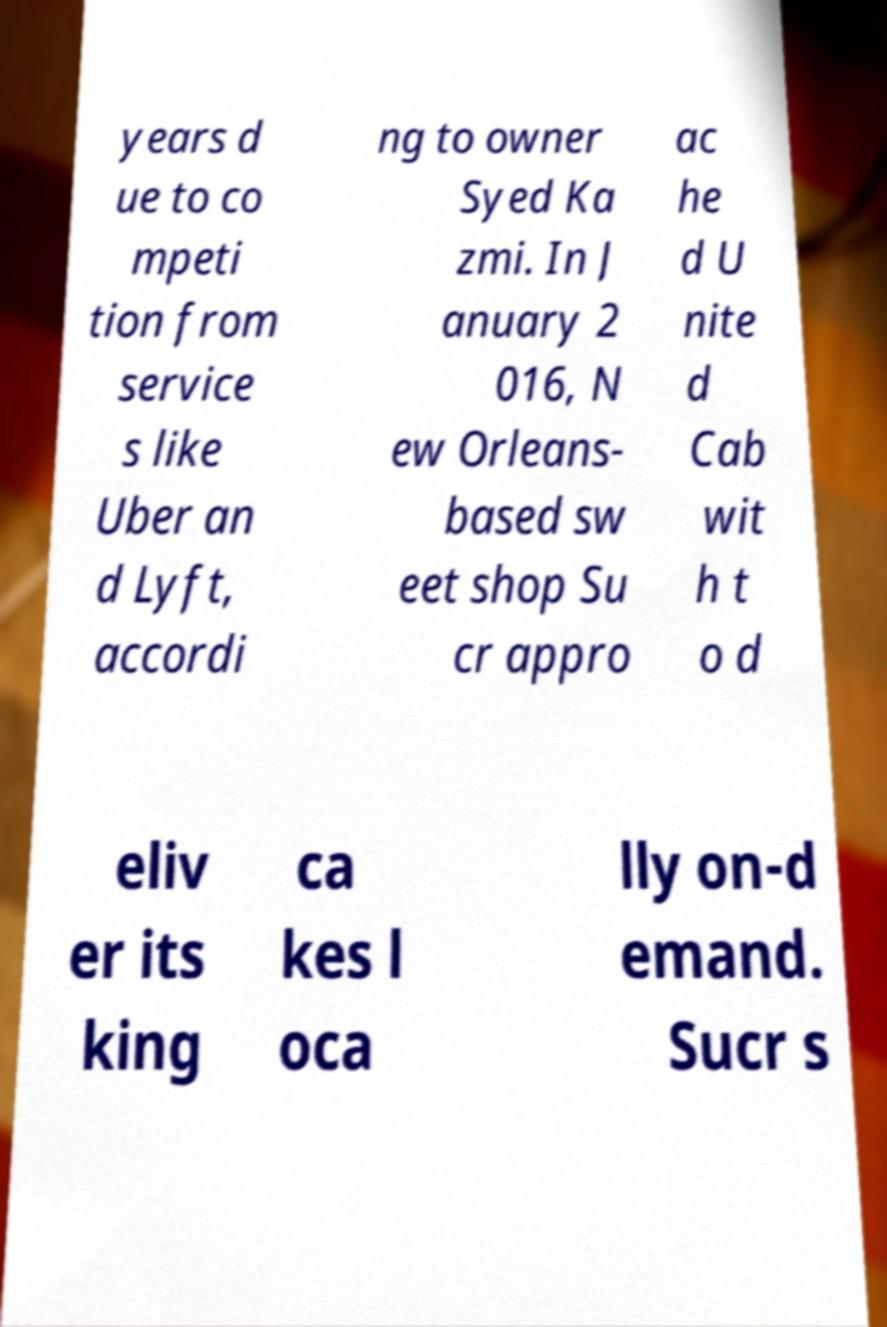Can you accurately transcribe the text from the provided image for me? years d ue to co mpeti tion from service s like Uber an d Lyft, accordi ng to owner Syed Ka zmi. In J anuary 2 016, N ew Orleans- based sw eet shop Su cr appro ac he d U nite d Cab wit h t o d eliv er its king ca kes l oca lly on-d emand. Sucr s 